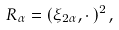<formula> <loc_0><loc_0><loc_500><loc_500>R _ { \alpha } = ( \xi _ { 2 \alpha } , \cdot \, ) ^ { 2 } \, ,</formula> 